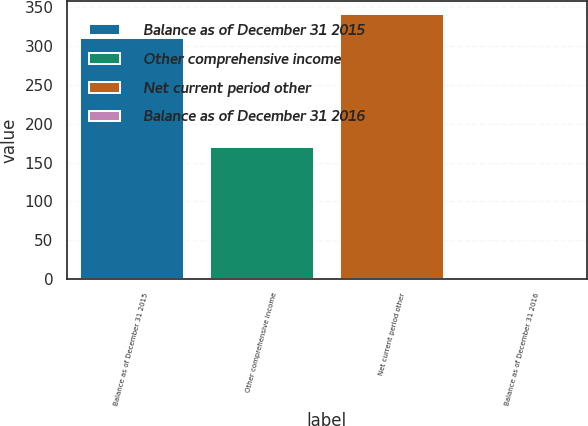<chart> <loc_0><loc_0><loc_500><loc_500><bar_chart><fcel>Balance as of December 31 2015<fcel>Other comprehensive income<fcel>Net current period other<fcel>Balance as of December 31 2016<nl><fcel>310<fcel>170<fcel>341<fcel>1<nl></chart> 